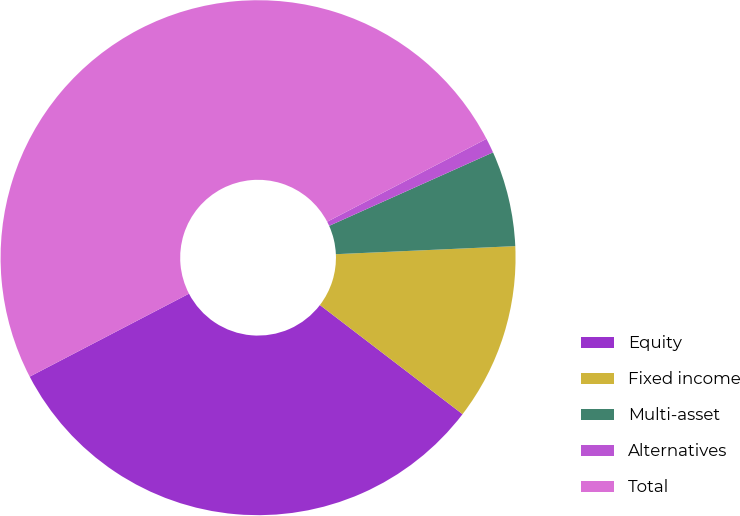Convert chart to OTSL. <chart><loc_0><loc_0><loc_500><loc_500><pie_chart><fcel>Equity<fcel>Fixed income<fcel>Multi-asset<fcel>Alternatives<fcel>Total<nl><fcel>31.96%<fcel>11.11%<fcel>5.99%<fcel>0.93%<fcel>50.0%<nl></chart> 